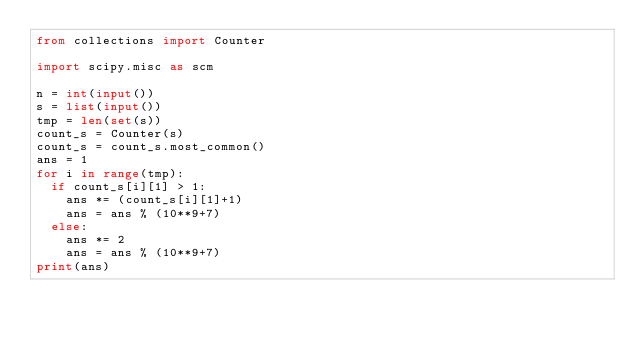<code> <loc_0><loc_0><loc_500><loc_500><_Python_>from collections import Counter

import scipy.misc as scm

n = int(input())
s = list(input())
tmp = len(set(s))
count_s = Counter(s)
count_s = count_s.most_common()
ans = 1
for i in range(tmp):
  if count_s[i][1] > 1:
    ans *= (count_s[i][1]+1)
    ans = ans % (10**9+7)
  else:
    ans *= 2
    ans = ans % (10**9+7)
print(ans)
</code> 